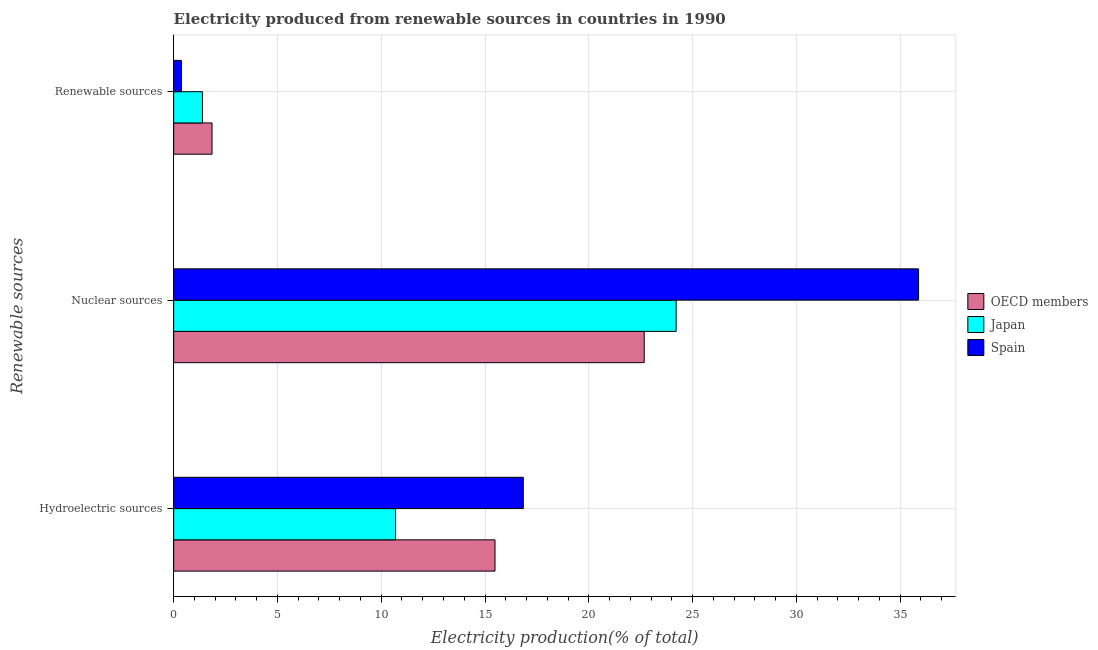How many groups of bars are there?
Your response must be concise. 3. Are the number of bars per tick equal to the number of legend labels?
Make the answer very short. Yes. Are the number of bars on each tick of the Y-axis equal?
Keep it short and to the point. Yes. How many bars are there on the 2nd tick from the bottom?
Offer a terse response. 3. What is the label of the 3rd group of bars from the top?
Offer a very short reply. Hydroelectric sources. What is the percentage of electricity produced by renewable sources in OECD members?
Ensure brevity in your answer.  1.85. Across all countries, what is the maximum percentage of electricity produced by nuclear sources?
Your answer should be compact. 35.89. Across all countries, what is the minimum percentage of electricity produced by renewable sources?
Provide a succinct answer. 0.37. In which country was the percentage of electricity produced by hydroelectric sources maximum?
Your response must be concise. Spain. What is the total percentage of electricity produced by renewable sources in the graph?
Keep it short and to the point. 3.61. What is the difference between the percentage of electricity produced by nuclear sources in Japan and that in OECD members?
Keep it short and to the point. 1.54. What is the difference between the percentage of electricity produced by hydroelectric sources in Spain and the percentage of electricity produced by renewable sources in Japan?
Make the answer very short. 15.46. What is the average percentage of electricity produced by renewable sources per country?
Ensure brevity in your answer.  1.2. What is the difference between the percentage of electricity produced by nuclear sources and percentage of electricity produced by hydroelectric sources in Spain?
Ensure brevity in your answer.  19.05. In how many countries, is the percentage of electricity produced by hydroelectric sources greater than 35 %?
Keep it short and to the point. 0. What is the ratio of the percentage of electricity produced by renewable sources in Japan to that in Spain?
Give a very brief answer. 3.73. Is the percentage of electricity produced by hydroelectric sources in OECD members less than that in Japan?
Your answer should be compact. No. What is the difference between the highest and the second highest percentage of electricity produced by hydroelectric sources?
Your answer should be compact. 1.36. What is the difference between the highest and the lowest percentage of electricity produced by nuclear sources?
Make the answer very short. 13.22. Is the sum of the percentage of electricity produced by nuclear sources in OECD members and Spain greater than the maximum percentage of electricity produced by renewable sources across all countries?
Provide a short and direct response. Yes. What does the 3rd bar from the bottom in Renewable sources represents?
Provide a succinct answer. Spain. Is it the case that in every country, the sum of the percentage of electricity produced by hydroelectric sources and percentage of electricity produced by nuclear sources is greater than the percentage of electricity produced by renewable sources?
Your answer should be very brief. Yes. How many bars are there?
Make the answer very short. 9. How many countries are there in the graph?
Provide a short and direct response. 3. Are the values on the major ticks of X-axis written in scientific E-notation?
Offer a very short reply. No. Does the graph contain any zero values?
Make the answer very short. No. Does the graph contain grids?
Your answer should be compact. Yes. Where does the legend appear in the graph?
Provide a succinct answer. Center right. How many legend labels are there?
Offer a terse response. 3. What is the title of the graph?
Your answer should be very brief. Electricity produced from renewable sources in countries in 1990. What is the label or title of the X-axis?
Provide a short and direct response. Electricity production(% of total). What is the label or title of the Y-axis?
Your answer should be compact. Renewable sources. What is the Electricity production(% of total) in OECD members in Hydroelectric sources?
Your answer should be very brief. 15.48. What is the Electricity production(% of total) of Japan in Hydroelectric sources?
Make the answer very short. 10.69. What is the Electricity production(% of total) of Spain in Hydroelectric sources?
Give a very brief answer. 16.84. What is the Electricity production(% of total) of OECD members in Nuclear sources?
Your answer should be very brief. 22.67. What is the Electricity production(% of total) of Japan in Nuclear sources?
Your answer should be very brief. 24.21. What is the Electricity production(% of total) in Spain in Nuclear sources?
Your response must be concise. 35.89. What is the Electricity production(% of total) in OECD members in Renewable sources?
Your response must be concise. 1.85. What is the Electricity production(% of total) in Japan in Renewable sources?
Your response must be concise. 1.39. What is the Electricity production(% of total) of Spain in Renewable sources?
Your answer should be compact. 0.37. Across all Renewable sources, what is the maximum Electricity production(% of total) in OECD members?
Offer a very short reply. 22.67. Across all Renewable sources, what is the maximum Electricity production(% of total) in Japan?
Provide a succinct answer. 24.21. Across all Renewable sources, what is the maximum Electricity production(% of total) in Spain?
Your answer should be compact. 35.89. Across all Renewable sources, what is the minimum Electricity production(% of total) of OECD members?
Give a very brief answer. 1.85. Across all Renewable sources, what is the minimum Electricity production(% of total) in Japan?
Ensure brevity in your answer.  1.39. Across all Renewable sources, what is the minimum Electricity production(% of total) of Spain?
Offer a terse response. 0.37. What is the total Electricity production(% of total) of OECD members in the graph?
Keep it short and to the point. 40. What is the total Electricity production(% of total) in Japan in the graph?
Keep it short and to the point. 36.28. What is the total Electricity production(% of total) of Spain in the graph?
Provide a short and direct response. 53.11. What is the difference between the Electricity production(% of total) in OECD members in Hydroelectric sources and that in Nuclear sources?
Your answer should be very brief. -7.19. What is the difference between the Electricity production(% of total) in Japan in Hydroelectric sources and that in Nuclear sources?
Your answer should be compact. -13.52. What is the difference between the Electricity production(% of total) in Spain in Hydroelectric sources and that in Nuclear sources?
Offer a terse response. -19.05. What is the difference between the Electricity production(% of total) of OECD members in Hydroelectric sources and that in Renewable sources?
Offer a terse response. 13.63. What is the difference between the Electricity production(% of total) in Japan in Hydroelectric sources and that in Renewable sources?
Make the answer very short. 9.3. What is the difference between the Electricity production(% of total) in Spain in Hydroelectric sources and that in Renewable sources?
Your response must be concise. 16.47. What is the difference between the Electricity production(% of total) in OECD members in Nuclear sources and that in Renewable sources?
Offer a very short reply. 20.82. What is the difference between the Electricity production(% of total) of Japan in Nuclear sources and that in Renewable sources?
Provide a short and direct response. 22.82. What is the difference between the Electricity production(% of total) in Spain in Nuclear sources and that in Renewable sources?
Offer a terse response. 35.52. What is the difference between the Electricity production(% of total) in OECD members in Hydroelectric sources and the Electricity production(% of total) in Japan in Nuclear sources?
Keep it short and to the point. -8.73. What is the difference between the Electricity production(% of total) in OECD members in Hydroelectric sources and the Electricity production(% of total) in Spain in Nuclear sources?
Provide a short and direct response. -20.41. What is the difference between the Electricity production(% of total) of Japan in Hydroelectric sources and the Electricity production(% of total) of Spain in Nuclear sources?
Make the answer very short. -25.2. What is the difference between the Electricity production(% of total) in OECD members in Hydroelectric sources and the Electricity production(% of total) in Japan in Renewable sources?
Ensure brevity in your answer.  14.1. What is the difference between the Electricity production(% of total) of OECD members in Hydroelectric sources and the Electricity production(% of total) of Spain in Renewable sources?
Make the answer very short. 15.11. What is the difference between the Electricity production(% of total) in Japan in Hydroelectric sources and the Electricity production(% of total) in Spain in Renewable sources?
Offer a very short reply. 10.32. What is the difference between the Electricity production(% of total) in OECD members in Nuclear sources and the Electricity production(% of total) in Japan in Renewable sources?
Provide a short and direct response. 21.28. What is the difference between the Electricity production(% of total) of OECD members in Nuclear sources and the Electricity production(% of total) of Spain in Renewable sources?
Provide a succinct answer. 22.3. What is the difference between the Electricity production(% of total) of Japan in Nuclear sources and the Electricity production(% of total) of Spain in Renewable sources?
Make the answer very short. 23.84. What is the average Electricity production(% of total) in OECD members per Renewable sources?
Offer a terse response. 13.33. What is the average Electricity production(% of total) of Japan per Renewable sources?
Offer a very short reply. 12.09. What is the average Electricity production(% of total) in Spain per Renewable sources?
Ensure brevity in your answer.  17.7. What is the difference between the Electricity production(% of total) of OECD members and Electricity production(% of total) of Japan in Hydroelectric sources?
Provide a succinct answer. 4.79. What is the difference between the Electricity production(% of total) in OECD members and Electricity production(% of total) in Spain in Hydroelectric sources?
Make the answer very short. -1.36. What is the difference between the Electricity production(% of total) in Japan and Electricity production(% of total) in Spain in Hydroelectric sources?
Give a very brief answer. -6.16. What is the difference between the Electricity production(% of total) of OECD members and Electricity production(% of total) of Japan in Nuclear sources?
Offer a very short reply. -1.54. What is the difference between the Electricity production(% of total) in OECD members and Electricity production(% of total) in Spain in Nuclear sources?
Make the answer very short. -13.22. What is the difference between the Electricity production(% of total) in Japan and Electricity production(% of total) in Spain in Nuclear sources?
Ensure brevity in your answer.  -11.68. What is the difference between the Electricity production(% of total) of OECD members and Electricity production(% of total) of Japan in Renewable sources?
Make the answer very short. 0.46. What is the difference between the Electricity production(% of total) of OECD members and Electricity production(% of total) of Spain in Renewable sources?
Make the answer very short. 1.48. What is the difference between the Electricity production(% of total) in Japan and Electricity production(% of total) in Spain in Renewable sources?
Your answer should be very brief. 1.01. What is the ratio of the Electricity production(% of total) in OECD members in Hydroelectric sources to that in Nuclear sources?
Keep it short and to the point. 0.68. What is the ratio of the Electricity production(% of total) of Japan in Hydroelectric sources to that in Nuclear sources?
Your answer should be compact. 0.44. What is the ratio of the Electricity production(% of total) in Spain in Hydroelectric sources to that in Nuclear sources?
Give a very brief answer. 0.47. What is the ratio of the Electricity production(% of total) of OECD members in Hydroelectric sources to that in Renewable sources?
Your response must be concise. 8.38. What is the ratio of the Electricity production(% of total) in Japan in Hydroelectric sources to that in Renewable sources?
Offer a terse response. 7.71. What is the ratio of the Electricity production(% of total) of Spain in Hydroelectric sources to that in Renewable sources?
Make the answer very short. 45.32. What is the ratio of the Electricity production(% of total) in OECD members in Nuclear sources to that in Renewable sources?
Give a very brief answer. 12.27. What is the ratio of the Electricity production(% of total) in Japan in Nuclear sources to that in Renewable sources?
Provide a succinct answer. 17.46. What is the ratio of the Electricity production(% of total) in Spain in Nuclear sources to that in Renewable sources?
Your answer should be compact. 96.56. What is the difference between the highest and the second highest Electricity production(% of total) of OECD members?
Provide a short and direct response. 7.19. What is the difference between the highest and the second highest Electricity production(% of total) of Japan?
Ensure brevity in your answer.  13.52. What is the difference between the highest and the second highest Electricity production(% of total) of Spain?
Provide a succinct answer. 19.05. What is the difference between the highest and the lowest Electricity production(% of total) in OECD members?
Offer a very short reply. 20.82. What is the difference between the highest and the lowest Electricity production(% of total) of Japan?
Offer a terse response. 22.82. What is the difference between the highest and the lowest Electricity production(% of total) of Spain?
Your response must be concise. 35.52. 